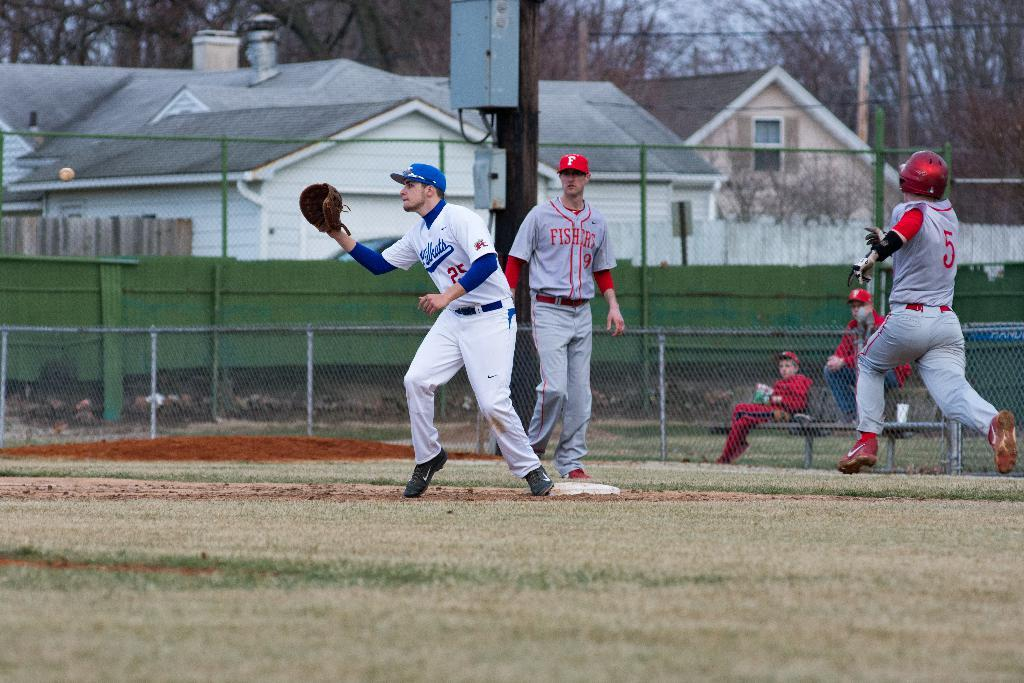<image>
Create a compact narrative representing the image presented. Player number 9 from Fishers walks in the field behind two players 